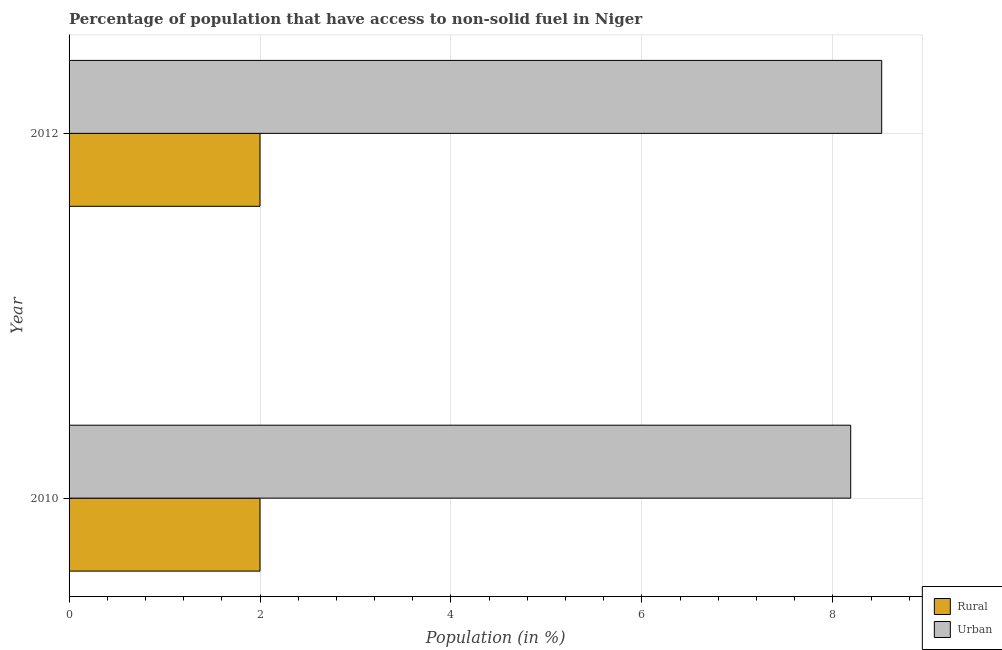How many groups of bars are there?
Give a very brief answer. 2. Are the number of bars per tick equal to the number of legend labels?
Keep it short and to the point. Yes. How many bars are there on the 2nd tick from the top?
Ensure brevity in your answer.  2. What is the label of the 2nd group of bars from the top?
Offer a terse response. 2010. In how many cases, is the number of bars for a given year not equal to the number of legend labels?
Offer a terse response. 0. What is the rural population in 2012?
Your answer should be compact. 2. Across all years, what is the maximum rural population?
Your answer should be very brief. 2. Across all years, what is the minimum rural population?
Offer a very short reply. 2. What is the total urban population in the graph?
Provide a short and direct response. 16.7. What is the difference between the rural population in 2010 and that in 2012?
Make the answer very short. 0. What is the difference between the urban population in 2010 and the rural population in 2012?
Keep it short and to the point. 6.19. In the year 2010, what is the difference between the urban population and rural population?
Ensure brevity in your answer.  6.19. Is the difference between the urban population in 2010 and 2012 greater than the difference between the rural population in 2010 and 2012?
Provide a succinct answer. No. In how many years, is the urban population greater than the average urban population taken over all years?
Offer a terse response. 1. What does the 2nd bar from the top in 2012 represents?
Give a very brief answer. Rural. What does the 2nd bar from the bottom in 2010 represents?
Ensure brevity in your answer.  Urban. How many bars are there?
Provide a short and direct response. 4. How many years are there in the graph?
Your answer should be compact. 2. Are the values on the major ticks of X-axis written in scientific E-notation?
Keep it short and to the point. No. Where does the legend appear in the graph?
Your response must be concise. Bottom right. How many legend labels are there?
Make the answer very short. 2. How are the legend labels stacked?
Your answer should be very brief. Vertical. What is the title of the graph?
Offer a very short reply. Percentage of population that have access to non-solid fuel in Niger. Does "Canada" appear as one of the legend labels in the graph?
Your answer should be compact. No. What is the label or title of the X-axis?
Your response must be concise. Population (in %). What is the Population (in %) of Rural in 2010?
Offer a terse response. 2. What is the Population (in %) in Urban in 2010?
Provide a succinct answer. 8.19. What is the Population (in %) of Rural in 2012?
Offer a terse response. 2. What is the Population (in %) in Urban in 2012?
Your response must be concise. 8.51. Across all years, what is the maximum Population (in %) in Rural?
Provide a short and direct response. 2. Across all years, what is the maximum Population (in %) of Urban?
Your answer should be very brief. 8.51. Across all years, what is the minimum Population (in %) of Rural?
Provide a short and direct response. 2. Across all years, what is the minimum Population (in %) of Urban?
Give a very brief answer. 8.19. What is the total Population (in %) of Urban in the graph?
Ensure brevity in your answer.  16.7. What is the difference between the Population (in %) of Rural in 2010 and that in 2012?
Your response must be concise. 0. What is the difference between the Population (in %) of Urban in 2010 and that in 2012?
Provide a succinct answer. -0.32. What is the difference between the Population (in %) in Rural in 2010 and the Population (in %) in Urban in 2012?
Ensure brevity in your answer.  -6.51. What is the average Population (in %) of Urban per year?
Your answer should be compact. 8.35. In the year 2010, what is the difference between the Population (in %) of Rural and Population (in %) of Urban?
Ensure brevity in your answer.  -6.19. In the year 2012, what is the difference between the Population (in %) of Rural and Population (in %) of Urban?
Your answer should be very brief. -6.51. What is the ratio of the Population (in %) of Urban in 2010 to that in 2012?
Give a very brief answer. 0.96. What is the difference between the highest and the second highest Population (in %) in Rural?
Provide a short and direct response. 0. What is the difference between the highest and the second highest Population (in %) of Urban?
Provide a short and direct response. 0.32. What is the difference between the highest and the lowest Population (in %) in Urban?
Provide a short and direct response. 0.32. 